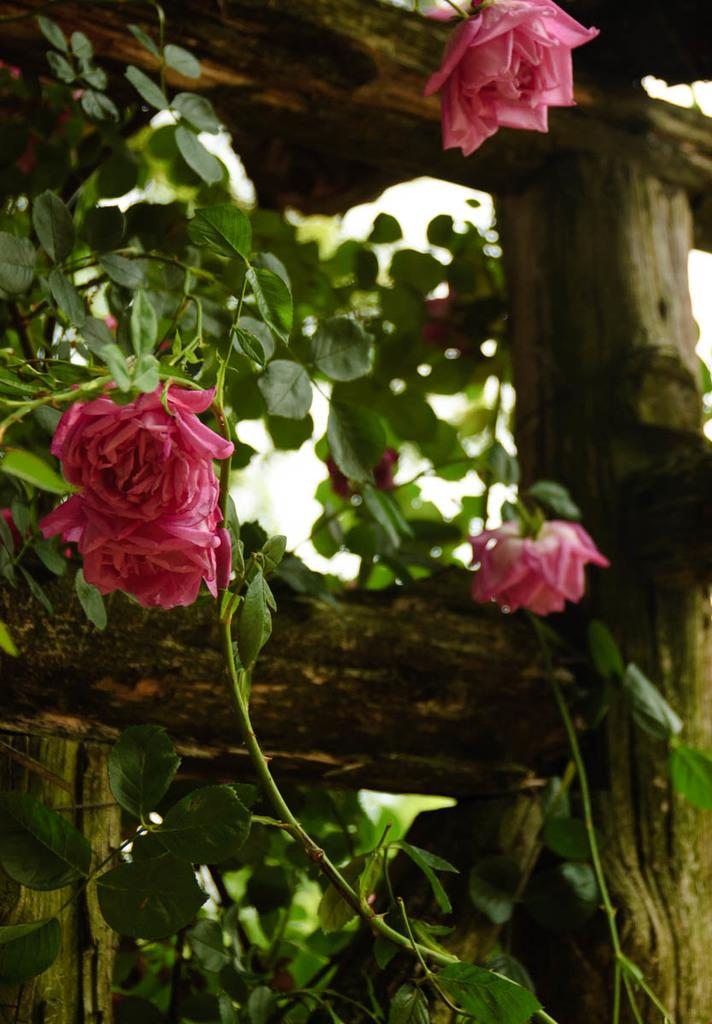What type of plant parts can be seen in the image? There are leaves, stems, and flowers in the image. Are there any additional materials present in the image? Yes, there are wooden sticks in the image. What type of mouth can be seen on the flowers in the image? There are no mouths present on the flowers in the image, as flowers do not have mouths. 